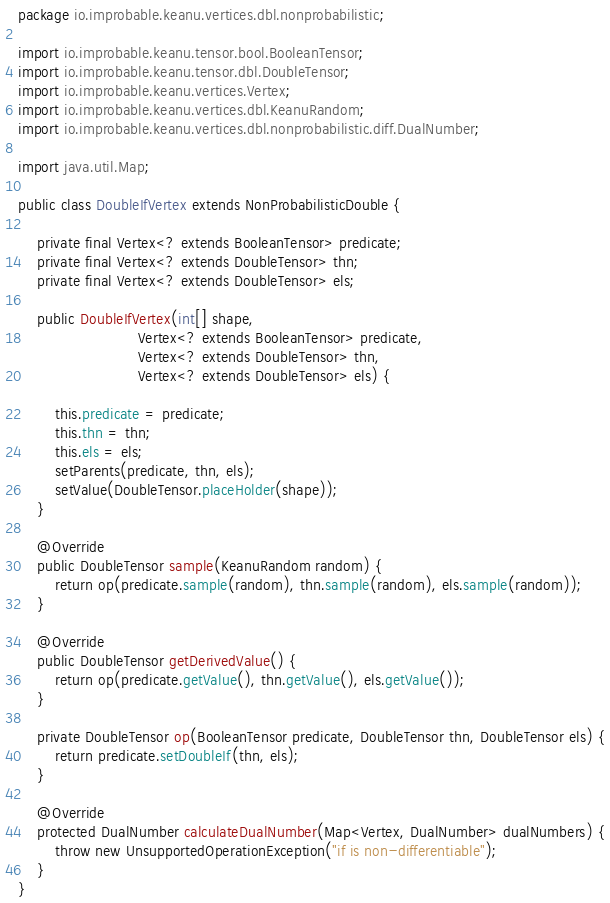<code> <loc_0><loc_0><loc_500><loc_500><_Java_>package io.improbable.keanu.vertices.dbl.nonprobabilistic;

import io.improbable.keanu.tensor.bool.BooleanTensor;
import io.improbable.keanu.tensor.dbl.DoubleTensor;
import io.improbable.keanu.vertices.Vertex;
import io.improbable.keanu.vertices.dbl.KeanuRandom;
import io.improbable.keanu.vertices.dbl.nonprobabilistic.diff.DualNumber;

import java.util.Map;

public class DoubleIfVertex extends NonProbabilisticDouble {

    private final Vertex<? extends BooleanTensor> predicate;
    private final Vertex<? extends DoubleTensor> thn;
    private final Vertex<? extends DoubleTensor> els;

    public DoubleIfVertex(int[] shape,
                          Vertex<? extends BooleanTensor> predicate,
                          Vertex<? extends DoubleTensor> thn,
                          Vertex<? extends DoubleTensor> els) {

        this.predicate = predicate;
        this.thn = thn;
        this.els = els;
        setParents(predicate, thn, els);
        setValue(DoubleTensor.placeHolder(shape));
    }

    @Override
    public DoubleTensor sample(KeanuRandom random) {
        return op(predicate.sample(random), thn.sample(random), els.sample(random));
    }

    @Override
    public DoubleTensor getDerivedValue() {
        return op(predicate.getValue(), thn.getValue(), els.getValue());
    }

    private DoubleTensor op(BooleanTensor predicate, DoubleTensor thn, DoubleTensor els) {
        return predicate.setDoubleIf(thn, els);
    }

    @Override
    protected DualNumber calculateDualNumber(Map<Vertex, DualNumber> dualNumbers) {
        throw new UnsupportedOperationException("if is non-differentiable");
    }
}
</code> 